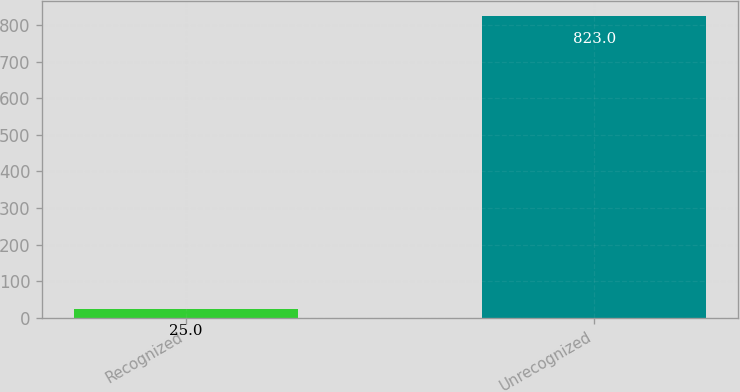Convert chart to OTSL. <chart><loc_0><loc_0><loc_500><loc_500><bar_chart><fcel>Recognized<fcel>Unrecognized<nl><fcel>25<fcel>823<nl></chart> 